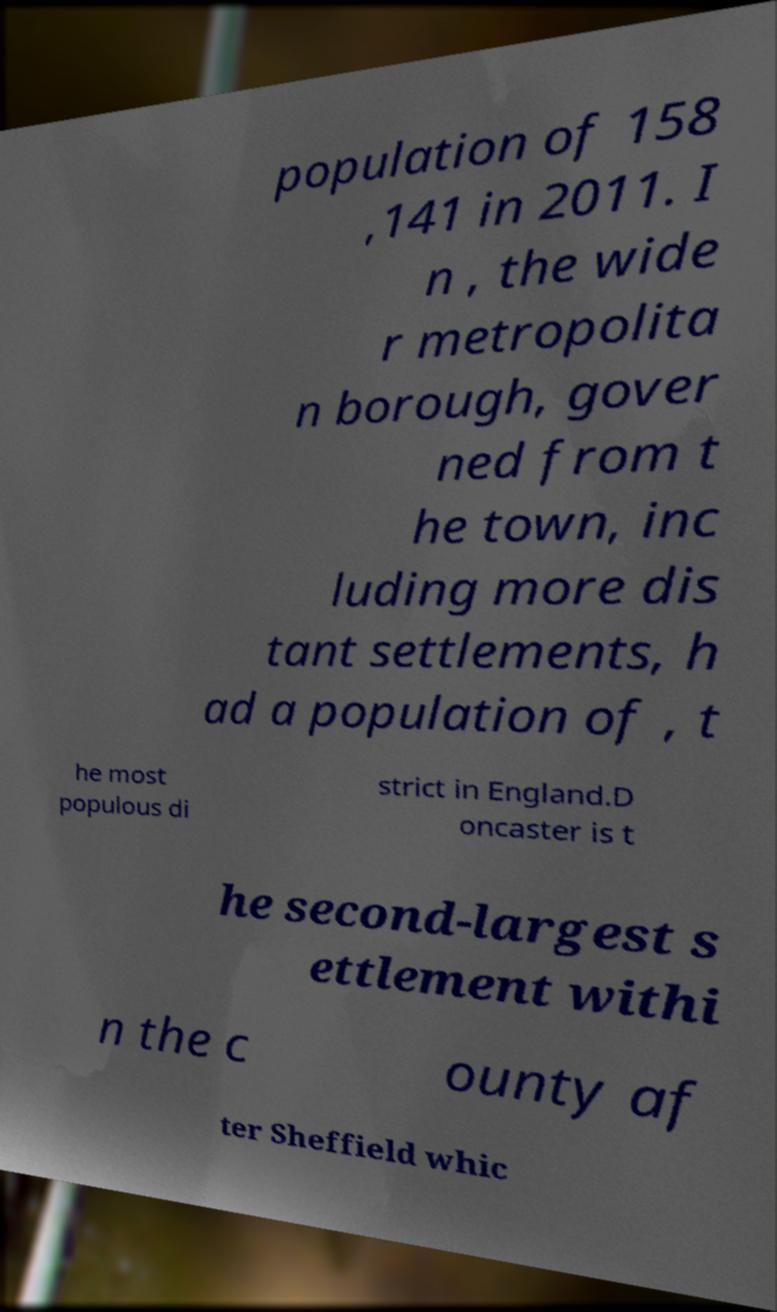Please identify and transcribe the text found in this image. population of 158 ,141 in 2011. I n , the wide r metropolita n borough, gover ned from t he town, inc luding more dis tant settlements, h ad a population of , t he most populous di strict in England.D oncaster is t he second-largest s ettlement withi n the c ounty af ter Sheffield whic 